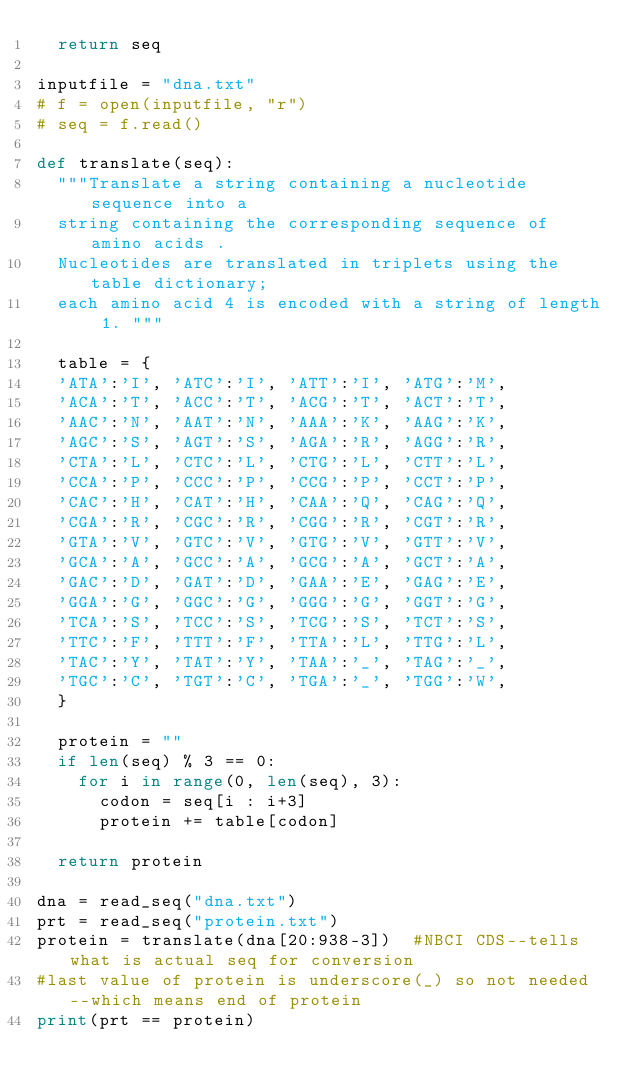Convert code to text. <code><loc_0><loc_0><loc_500><loc_500><_Python_>  return seq

inputfile = "dna.txt"
# f = open(inputfile, "r")
# seq = f.read()

def translate(seq):
  """Translate a string containing a nucleotide sequence into a 
  string containing the corresponding sequence of amino acids . 
  Nucleotides are translated in triplets using the table dictionary; 
  each amino acid 4 is encoded with a string of length 1. """

  table = {
  'ATA':'I', 'ATC':'I', 'ATT':'I', 'ATG':'M',
  'ACA':'T', 'ACC':'T', 'ACG':'T', 'ACT':'T',
  'AAC':'N', 'AAT':'N', 'AAA':'K', 'AAG':'K',
  'AGC':'S', 'AGT':'S', 'AGA':'R', 'AGG':'R',
  'CTA':'L', 'CTC':'L', 'CTG':'L', 'CTT':'L',
  'CCA':'P', 'CCC':'P', 'CCG':'P', 'CCT':'P',
  'CAC':'H', 'CAT':'H', 'CAA':'Q', 'CAG':'Q',
  'CGA':'R', 'CGC':'R', 'CGG':'R', 'CGT':'R',
  'GTA':'V', 'GTC':'V', 'GTG':'V', 'GTT':'V',
  'GCA':'A', 'GCC':'A', 'GCG':'A', 'GCT':'A',
  'GAC':'D', 'GAT':'D', 'GAA':'E', 'GAG':'E',
  'GGA':'G', 'GGC':'G', 'GGG':'G', 'GGT':'G',
  'TCA':'S', 'TCC':'S', 'TCG':'S', 'TCT':'S',
  'TTC':'F', 'TTT':'F', 'TTA':'L', 'TTG':'L',
  'TAC':'Y', 'TAT':'Y', 'TAA':'_', 'TAG':'_',
  'TGC':'C', 'TGT':'C', 'TGA':'_', 'TGG':'W',
  }

  protein = ""
  if len(seq) % 3 == 0:
    for i in range(0, len(seq), 3): 
      codon = seq[i : i+3]
      protein += table[codon]

  return protein

dna = read_seq("dna.txt")
prt = read_seq("protein.txt")
protein = translate(dna[20:938-3])  #NBCI CDS--tells what is actual seq for conversion
#last value of protein is underscore(_) so not needed--which means end of protein
print(prt == protein)
</code> 